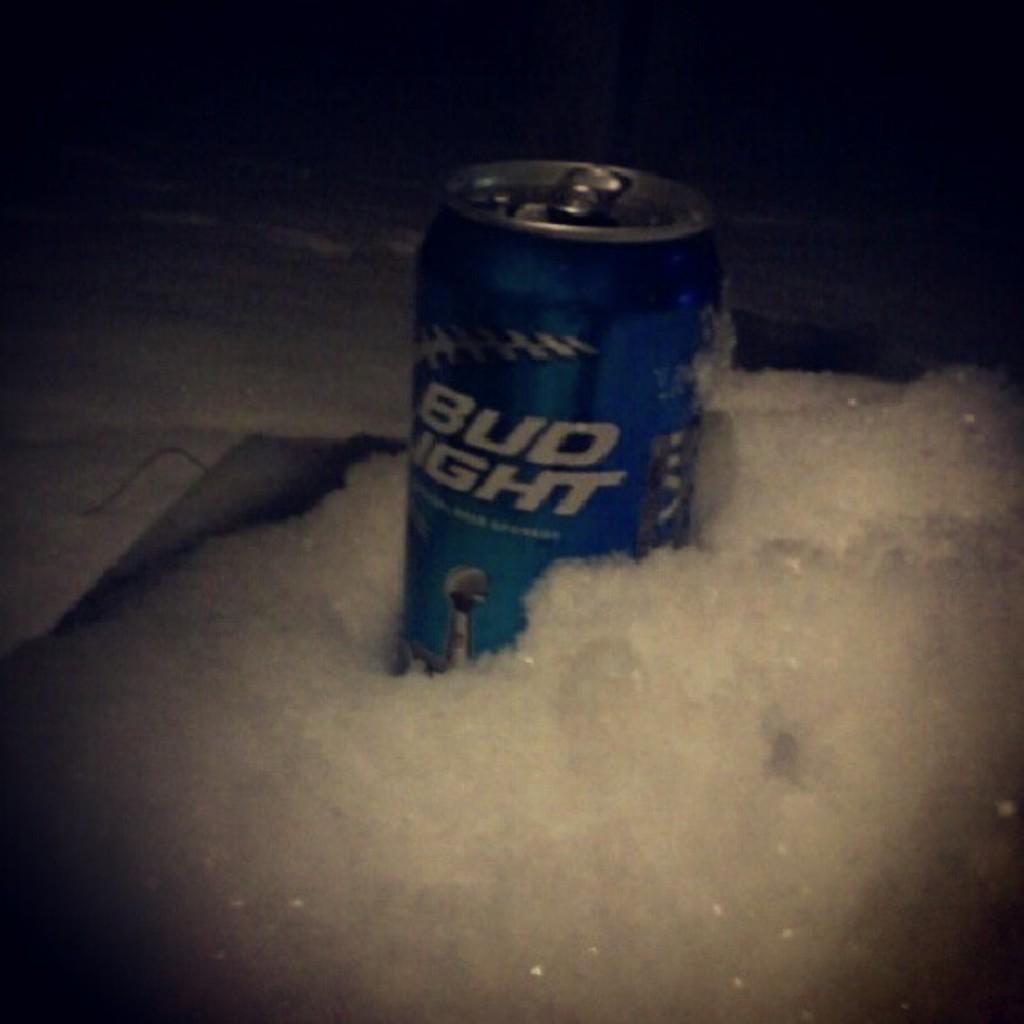<image>
Write a terse but informative summary of the picture. a Bud Light can that has a lot of suds around 